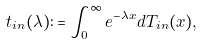Convert formula to latex. <formula><loc_0><loc_0><loc_500><loc_500>t _ { i n } ( \lambda ) \colon = \int _ { 0 } ^ { \infty } e ^ { - \lambda x } d T _ { i n } ( x ) ,</formula> 